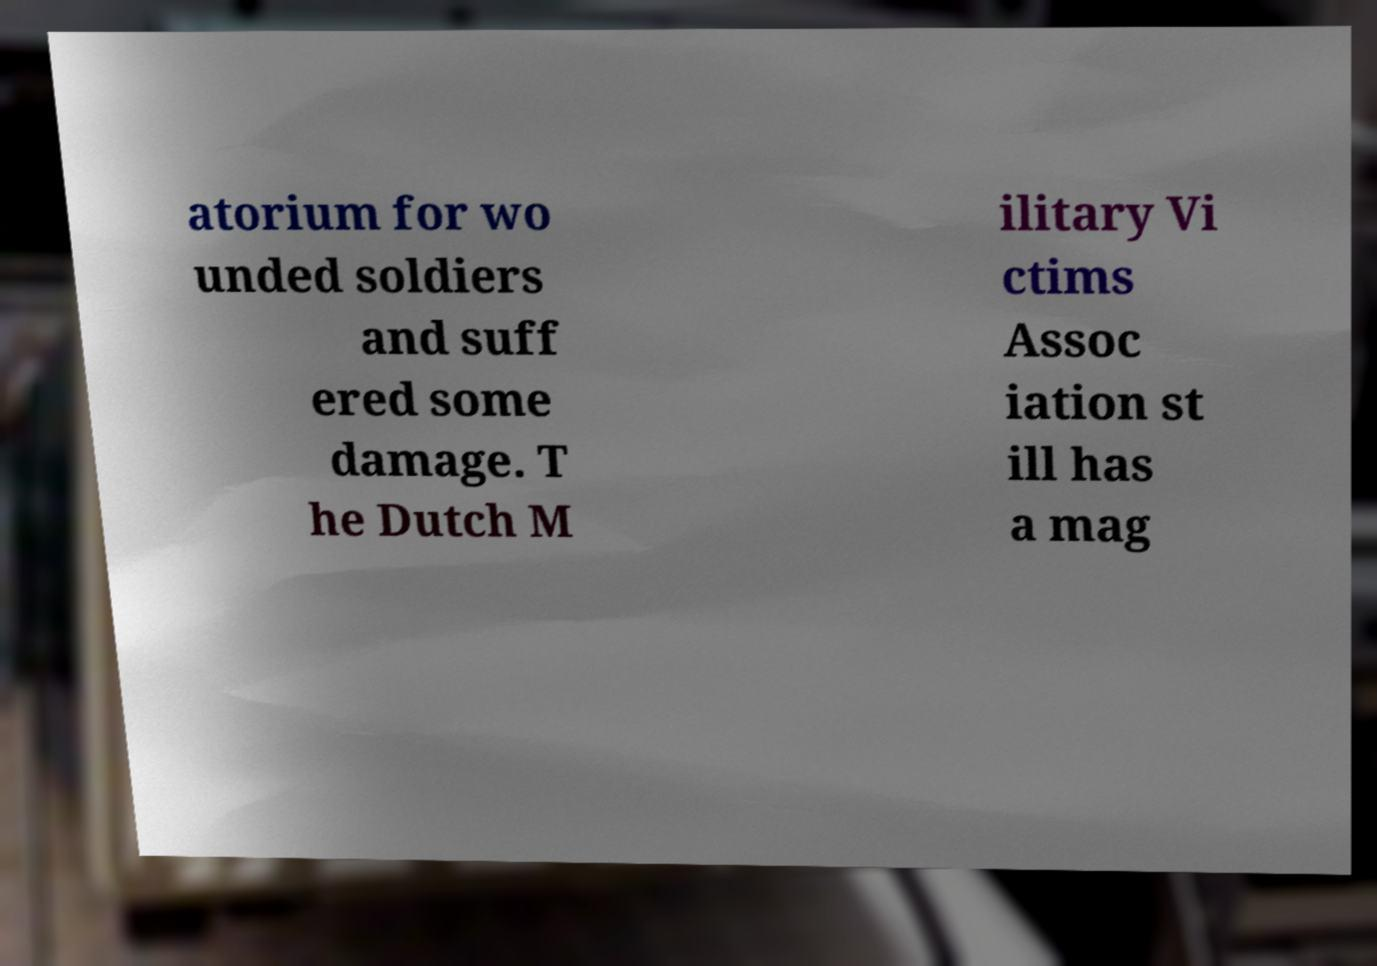Please identify and transcribe the text found in this image. atorium for wo unded soldiers and suff ered some damage. T he Dutch M ilitary Vi ctims Assoc iation st ill has a mag 